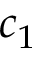Convert formula to latex. <formula><loc_0><loc_0><loc_500><loc_500>c _ { 1 }</formula> 